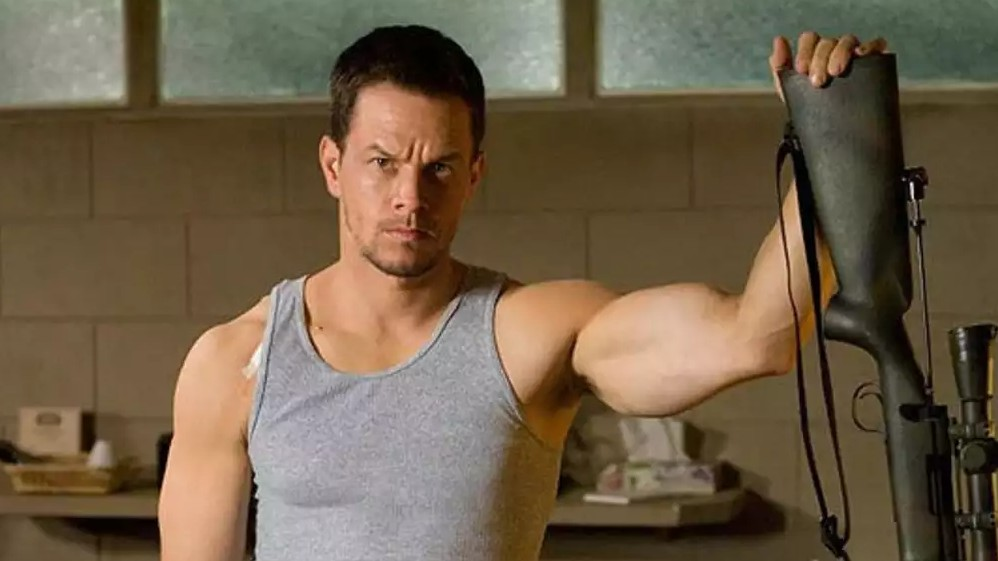Imagine the character's day-to-day life if he were a superhero in disguise. In his day-to-day life, this character masquerades as an ordinary personal trainer, guiding clients through rigorous workouts with an air of professionalism. After hours, he transforms into his superhero alter ego, engaging in secretive nightly patrols to protect the city from hidden threats. Balancing his mundane routine with covert superhero activities, he must constantly navigate the challenge of maintaining his anonymity. By day, he mentors clients to build their physique and confidence; by night, he combats crime with unmatched strength and a determination to uphold justice. His dual existence is a constant juggle, ensuring that neither facet of his life compromises the other, all while keeping his extraordinary abilities under wraps. 